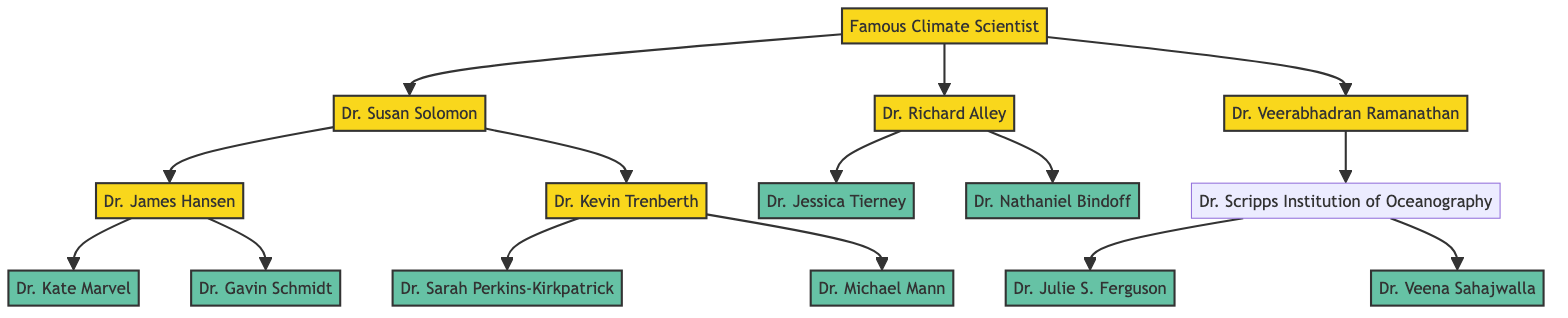What is the name of the top-level climate scientist? The diagram starts with "Famous Climate Scientist" as the root node, which is at the top of the family tree structure.
Answer: Famous Climate Scientist How many children does Dr. Susan Solomon have? Looking at Dr. Susan Solomon's node, it connects to two children nodes: Dr. James Hansen and Dr. Kevin Trenberth, totaling two.
Answer: 2 What is the role of Dr. Kate Marvel? Dr. Kate Marvel is listed as a child of Dr. James Hansen and is explicitly identified in the diagram as a "Climate Modeler."
Answer: Climate Modeler Who is the mentor of Dr. Michael Mann? Dr. Michael Mann is a child of Dr. Kevin Trenberth, thus making Dr. Kevin Trenberth his mentor in the lineage.
Answer: Dr. Kevin Trenberth Which institution is associated with Dr. Nathaniel Bindoff? The diagram shows that Dr. Nathaniel Bindoff is a child of Dr. Richard Alley and is tied to "University of Tasmania," which is his associated institution.
Answer: University of Tasmania How many total branches stem from the "Famous Climate Scientist"? The root node "Famous Climate Scientist" has three direct connections or branches leading to nodes representing Dr. Susan Solomon, Dr. Richard Alley, and Dr. Veerabhadran Ramanathan.
Answer: 3 Who is the child of Dr. Scripps Institution of Oceanography? The diagram identifies Dr. Scripps Institution of Oceanography as having two children: Dr. Julie S. Ferguson and Dr. Veena Sahajwalla. Therefore, these are the children linked to that node.
Answer: Dr. Julie S. Ferguson and Dr. Veena Sahajwalla Which scientist at NASA has a mentor in the diagram? Dr. Kate Marvel and Dr. Gavin Schmidt are both children of Dr. James Hansen, who mentors them at NASA Goddard Institute for Space Studies.
Answer: Dr. James Hansen What is Dr. Julie S. Ferguson's role? Within the diagram, Dr. Julie S. Ferguson is labeled specifically as working in "Environmental Policy."
Answer: Environmental Policy 